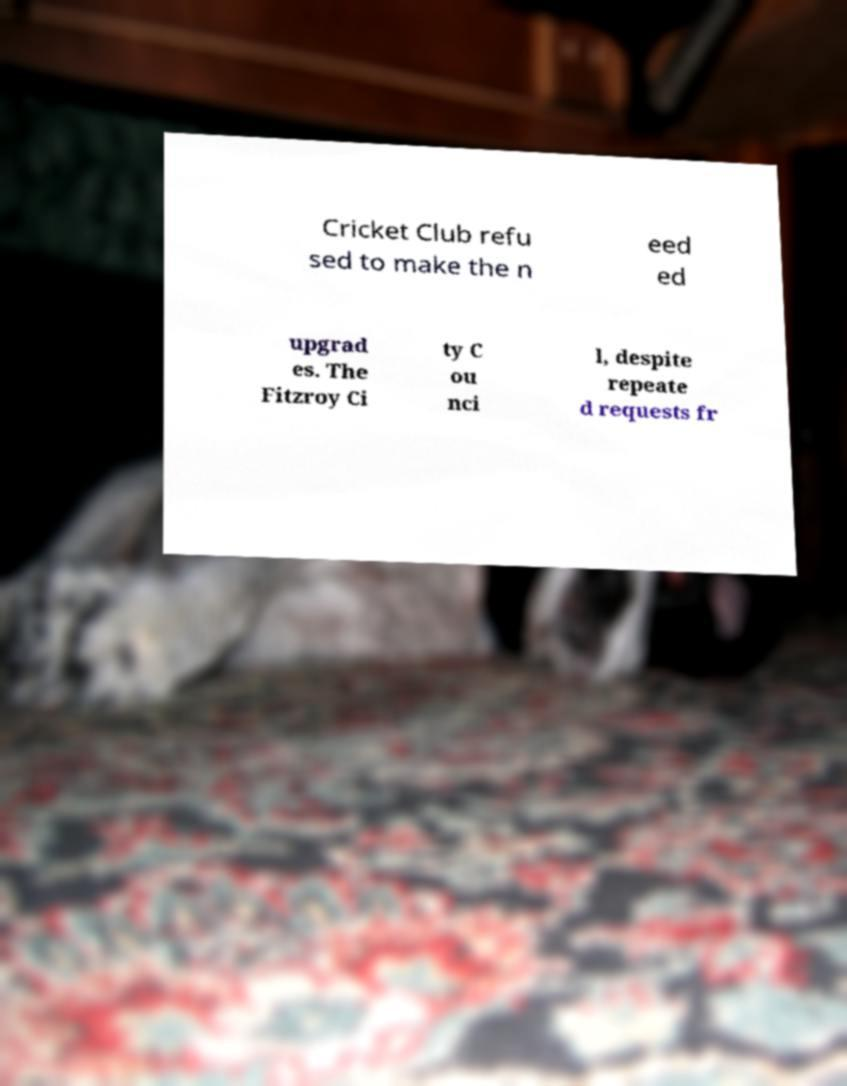I need the written content from this picture converted into text. Can you do that? Cricket Club refu sed to make the n eed ed upgrad es. The Fitzroy Ci ty C ou nci l, despite repeate d requests fr 